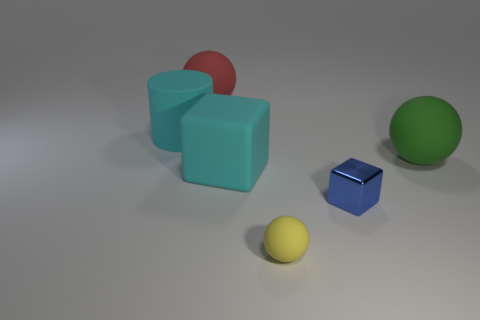Is the material of the tiny blue object the same as the cyan block?
Provide a short and direct response. No. Are there any red spheres in front of the cyan object that is on the right side of the big matte sphere that is behind the cyan cylinder?
Give a very brief answer. No. What number of other objects are there of the same shape as the green object?
Ensure brevity in your answer.  2. The object that is both behind the small metallic object and right of the small yellow rubber ball has what shape?
Offer a terse response. Sphere. There is a large sphere on the left side of the small object behind the matte thing that is in front of the blue object; what color is it?
Your answer should be very brief. Red. Is the number of balls on the left side of the big red matte thing greater than the number of balls that are on the right side of the yellow matte thing?
Provide a succinct answer. No. What number of other objects are there of the same size as the shiny object?
Provide a succinct answer. 1. There is a object that is the same color as the cylinder; what size is it?
Make the answer very short. Large. What material is the ball that is behind the rubber object that is on the left side of the large red ball?
Provide a succinct answer. Rubber. There is a tiny blue metallic thing; are there any metallic cubes in front of it?
Make the answer very short. No. 